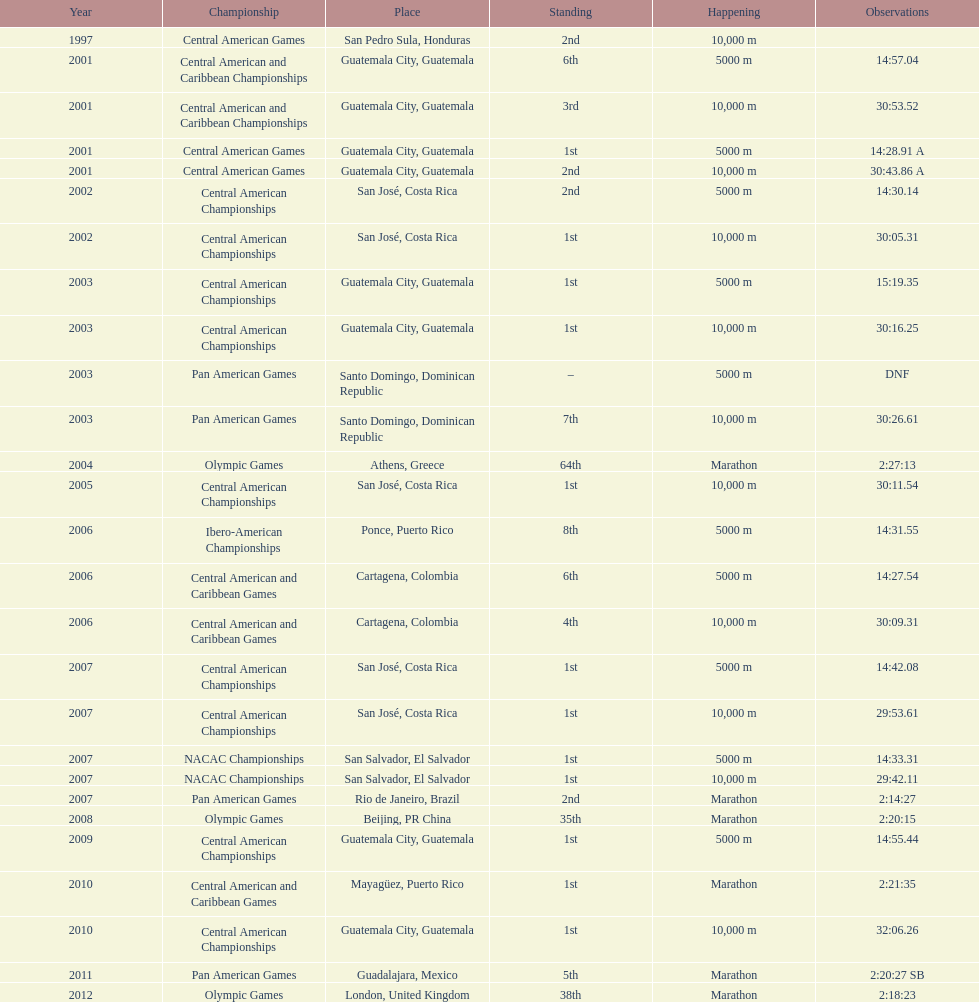Tell me the number of times they competed in guatamala. 5. 